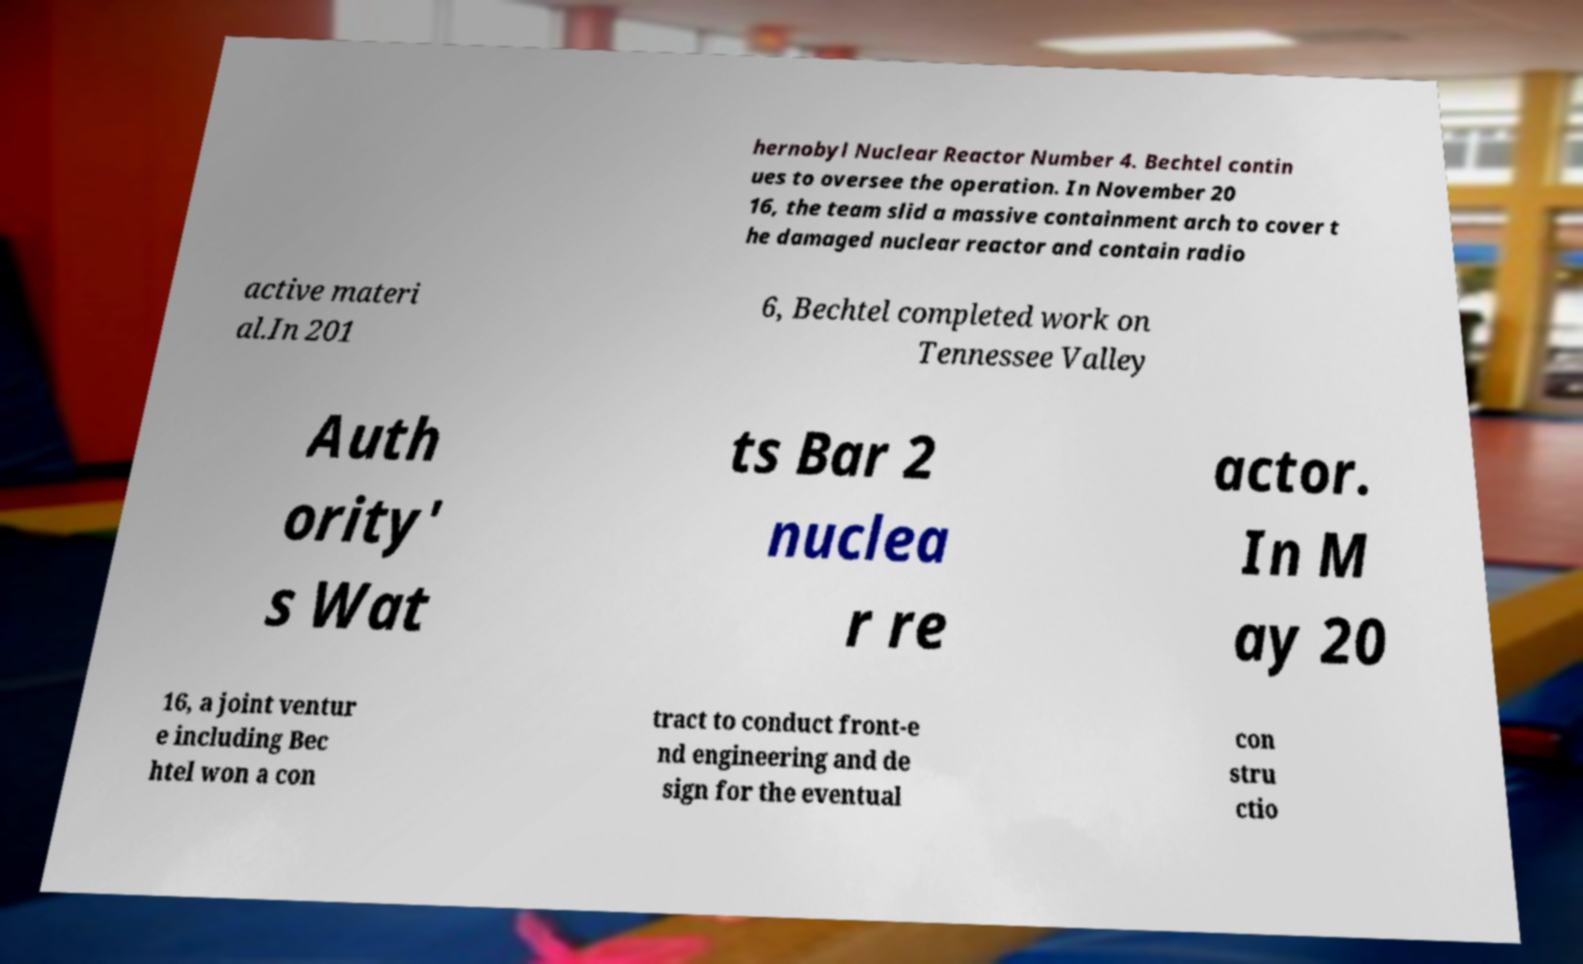What messages or text are displayed in this image? I need them in a readable, typed format. hernobyl Nuclear Reactor Number 4. Bechtel contin ues to oversee the operation. In November 20 16, the team slid a massive containment arch to cover t he damaged nuclear reactor and contain radio active materi al.In 201 6, Bechtel completed work on Tennessee Valley Auth ority' s Wat ts Bar 2 nuclea r re actor. In M ay 20 16, a joint ventur e including Bec htel won a con tract to conduct front-e nd engineering and de sign for the eventual con stru ctio 